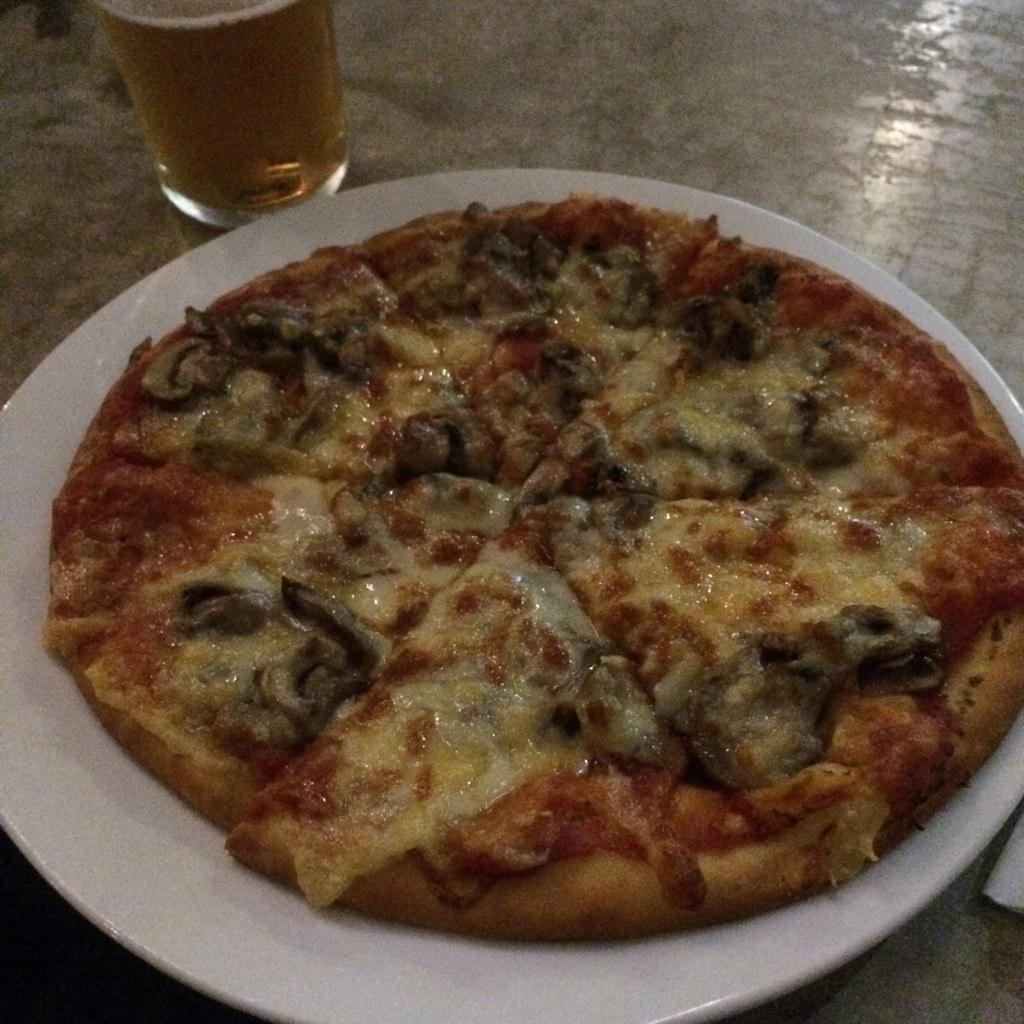What is on the platform in the image? There is a plate and a glass on the platform. What is on the plate? There is a pizza on the plate. What is in the glass? There is liquid in the glass. What type of cable is connected to the pizza in the image? There is no cable connected to the pizza in the image. What degree of heat is required to melt the jelly in the image? There is no jelly present in the image. 